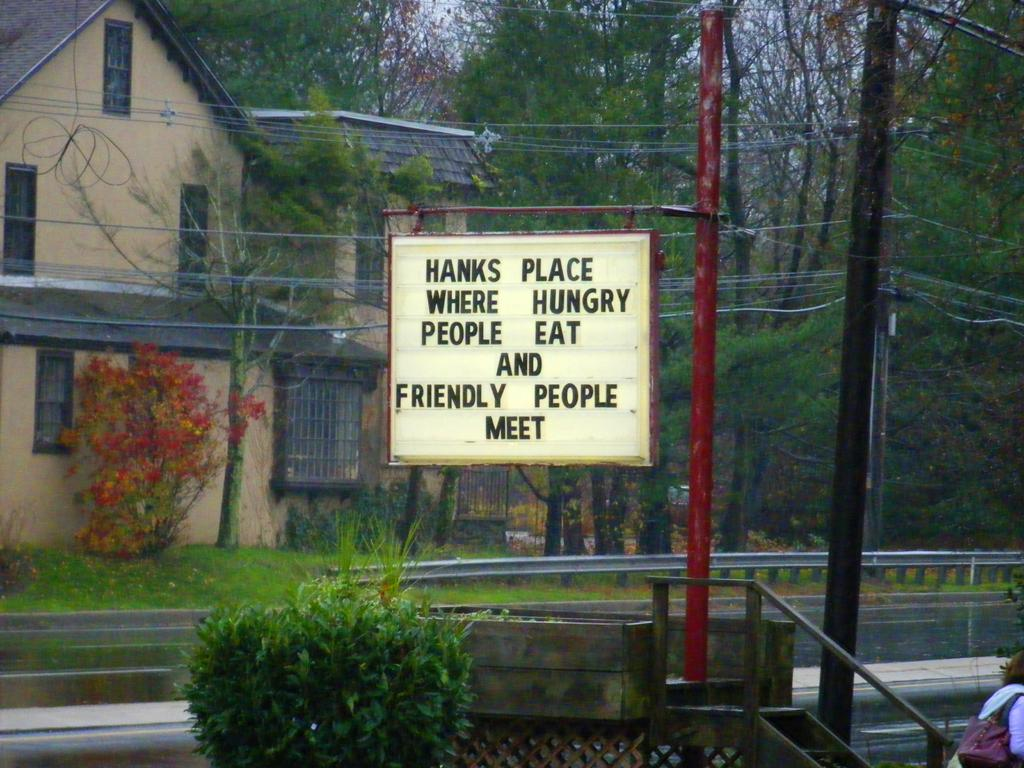What type of structure can be seen on the left side of the image? There is a building with windows on the left side of the image. What is present along the sides of the image? There is a railing and poles with wires in the image. What type of vegetation is visible in the image? There are plants and trees in the image. Can you tell me how many vases are placed on the coast in the image? There is no coast or vase present in the image. What type of credit can be seen on the building in the image? There is no credit or indication of any financial institution on the building in the image. 